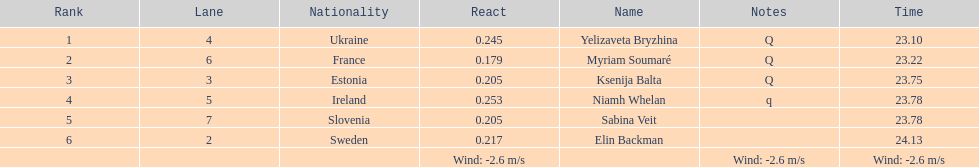Name of athlete who came in first in heat 1 of the women's 200 metres Yelizaveta Bryzhina. 